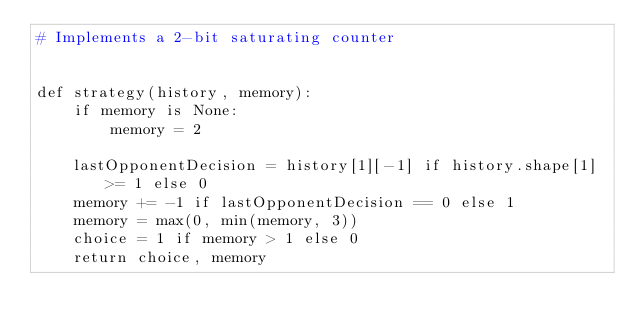Convert code to text. <code><loc_0><loc_0><loc_500><loc_500><_Python_># Implements a 2-bit saturating counter


def strategy(history, memory):
    if memory is None:
        memory = 2

    lastOpponentDecision = history[1][-1] if history.shape[1] >= 1 else 0
    memory += -1 if lastOpponentDecision == 0 else 1
    memory = max(0, min(memory, 3))
    choice = 1 if memory > 1 else 0
    return choice, memory
</code> 